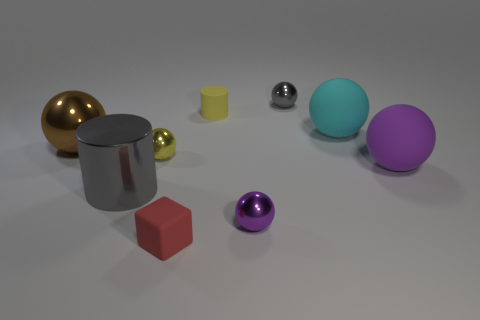Subtract 3 balls. How many balls are left? 3 Subtract all cyan spheres. How many spheres are left? 5 Subtract all cyan matte spheres. How many spheres are left? 5 Add 1 gray cylinders. How many objects exist? 10 Subtract all brown balls. Subtract all red cylinders. How many balls are left? 5 Subtract all cylinders. How many objects are left? 7 Add 5 cyan rubber objects. How many cyan rubber objects are left? 6 Add 1 big brown things. How many big brown things exist? 2 Subtract 0 yellow cubes. How many objects are left? 9 Subtract all tiny rubber cubes. Subtract all tiny yellow matte cylinders. How many objects are left? 7 